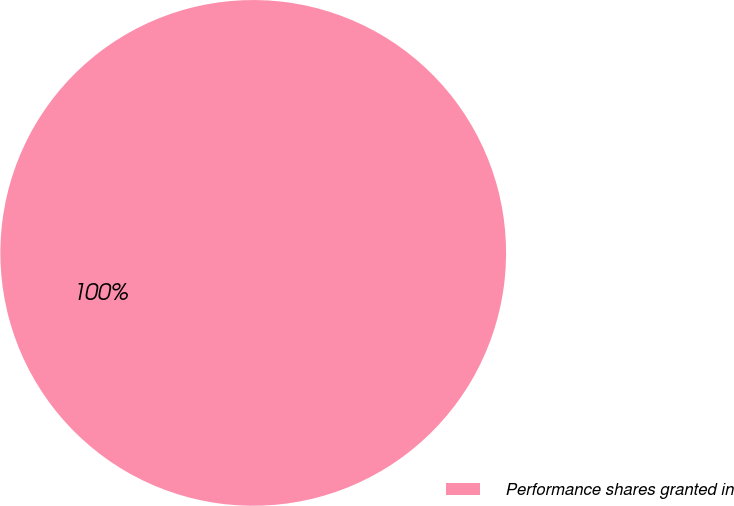<chart> <loc_0><loc_0><loc_500><loc_500><pie_chart><fcel>Performance shares granted in<nl><fcel>100.0%<nl></chart> 